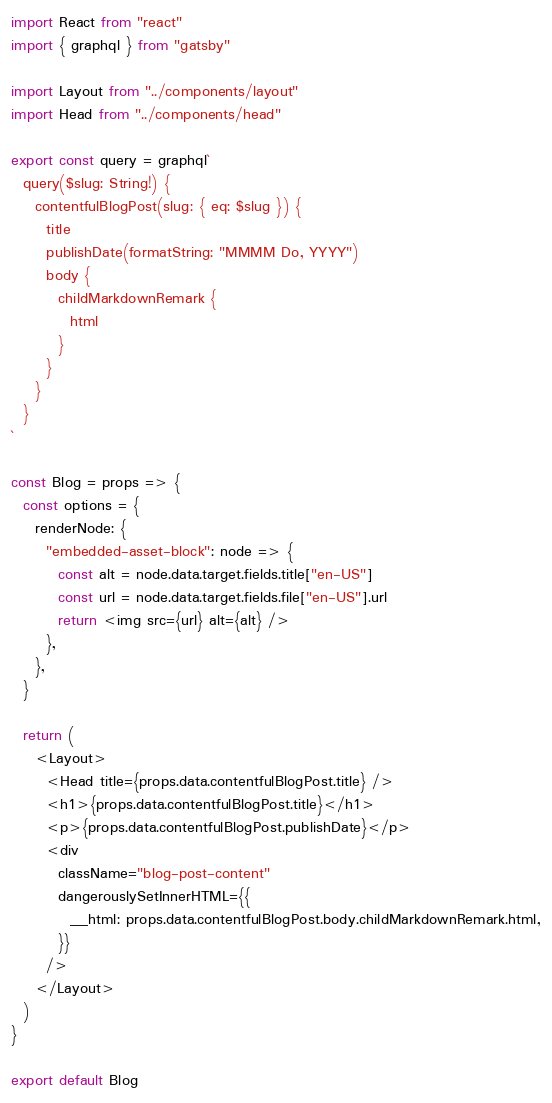<code> <loc_0><loc_0><loc_500><loc_500><_JavaScript_>import React from "react"
import { graphql } from "gatsby"

import Layout from "../components/layout"
import Head from "../components/head"

export const query = graphql`
  query($slug: String!) {
    contentfulBlogPost(slug: { eq: $slug }) {
      title
      publishDate(formatString: "MMMM Do, YYYY")
      body {
        childMarkdownRemark {
          html
        }
      }
    }
  }
`

const Blog = props => {
  const options = {
    renderNode: {
      "embedded-asset-block": node => {
        const alt = node.data.target.fields.title["en-US"]
        const url = node.data.target.fields.file["en-US"].url
        return <img src={url} alt={alt} />
      },
    },
  }

  return (
    <Layout>
      <Head title={props.data.contentfulBlogPost.title} />
      <h1>{props.data.contentfulBlogPost.title}</h1>
      <p>{props.data.contentfulBlogPost.publishDate}</p>
      <div
        className="blog-post-content"
        dangerouslySetInnerHTML={{
          __html: props.data.contentfulBlogPost.body.childMarkdownRemark.html,
        }}
      />
    </Layout>
  )
}

export default Blog
</code> 